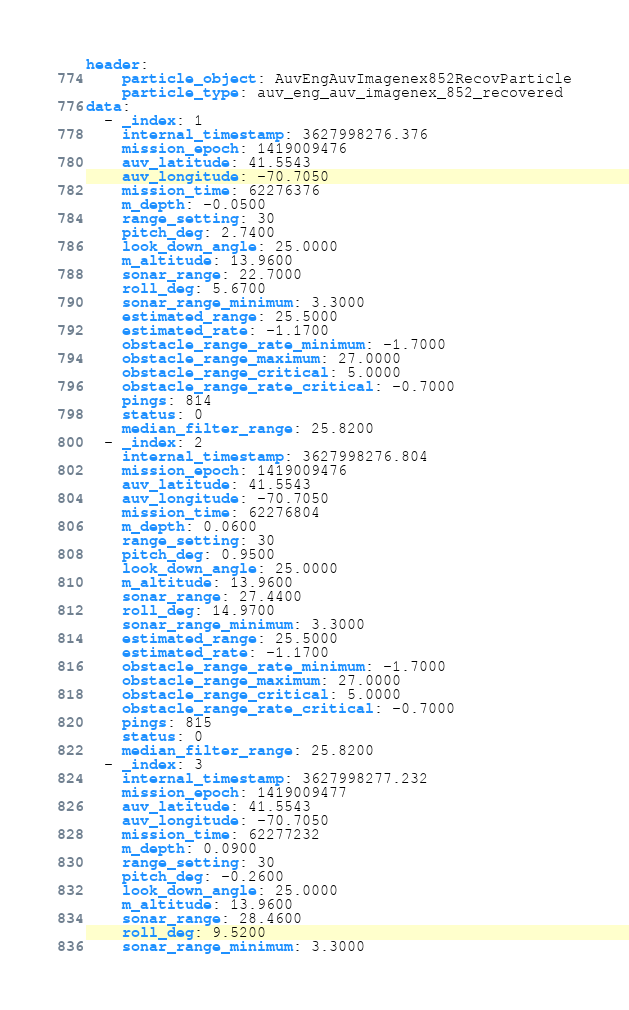<code> <loc_0><loc_0><loc_500><loc_500><_YAML_>header:
    particle_object: AuvEngAuvImagenex852RecovParticle
    particle_type: auv_eng_auv_imagenex_852_recovered
data:
  - _index: 1
    internal_timestamp: 3627998276.376
    mission_epoch: 1419009476
    auv_latitude: 41.5543
    auv_longitude: -70.7050
    mission_time: 62276376
    m_depth: -0.0500
    range_setting: 30
    pitch_deg: 2.7400
    look_down_angle: 25.0000
    m_altitude: 13.9600
    sonar_range: 22.7000
    roll_deg: 5.6700
    sonar_range_minimum: 3.3000
    estimated_range: 25.5000
    estimated_rate: -1.1700
    obstacle_range_rate_minimum: -1.7000
    obstacle_range_maximum: 27.0000
    obstacle_range_critical: 5.0000
    obstacle_range_rate_critical: -0.7000
    pings: 814
    status: 0
    median_filter_range: 25.8200
  - _index: 2
    internal_timestamp: 3627998276.804
    mission_epoch: 1419009476
    auv_latitude: 41.5543
    auv_longitude: -70.7050
    mission_time: 62276804
    m_depth: 0.0600
    range_setting: 30
    pitch_deg: 0.9500
    look_down_angle: 25.0000
    m_altitude: 13.9600
    sonar_range: 27.4400
    roll_deg: 14.9700
    sonar_range_minimum: 3.3000
    estimated_range: 25.5000
    estimated_rate: -1.1700
    obstacle_range_rate_minimum: -1.7000
    obstacle_range_maximum: 27.0000
    obstacle_range_critical: 5.0000
    obstacle_range_rate_critical: -0.7000
    pings: 815
    status: 0
    median_filter_range: 25.8200
  - _index: 3
    internal_timestamp: 3627998277.232
    mission_epoch: 1419009477
    auv_latitude: 41.5543
    auv_longitude: -70.7050
    mission_time: 62277232
    m_depth: 0.0900
    range_setting: 30
    pitch_deg: -0.2600
    look_down_angle: 25.0000
    m_altitude: 13.9600
    sonar_range: 28.4600
    roll_deg: 9.5200
    sonar_range_minimum: 3.3000</code> 